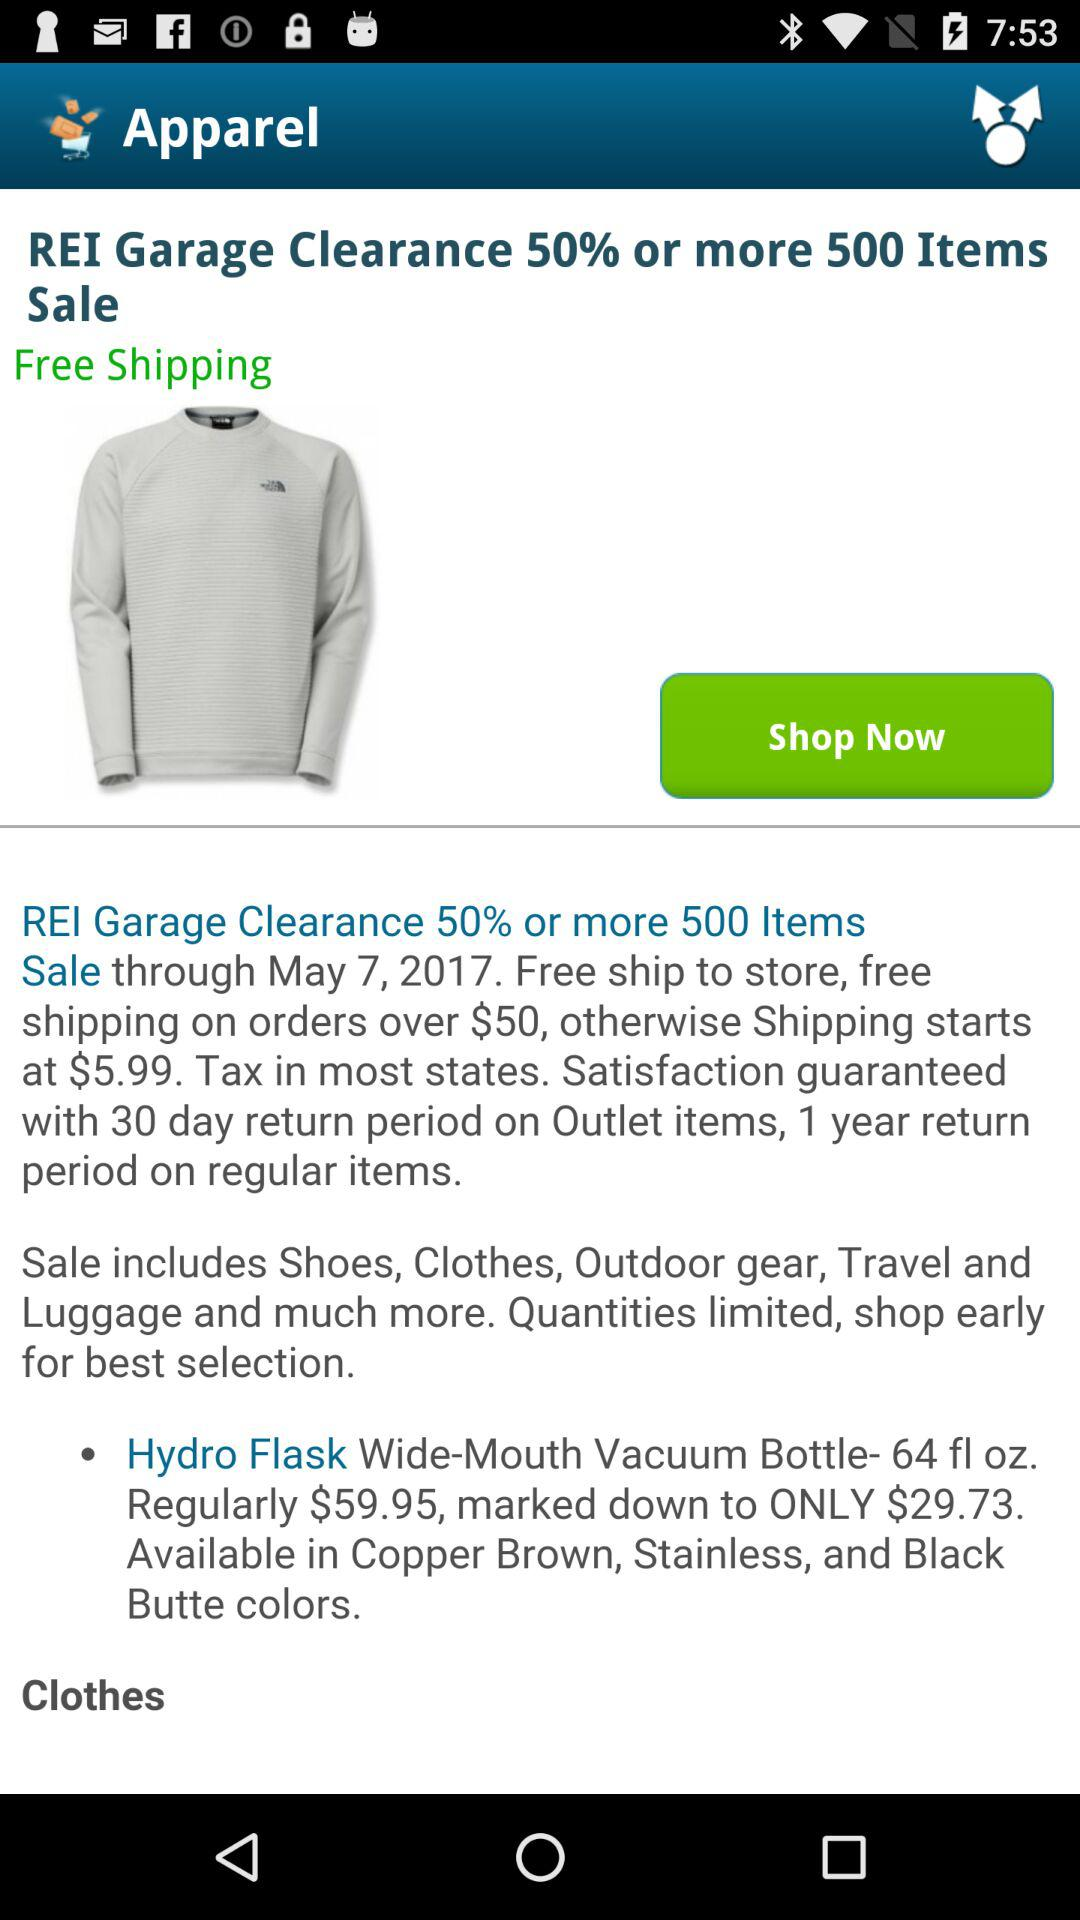How many items are included in the REI Garage Clearance sale?
Answer the question using a single word or phrase. 500 